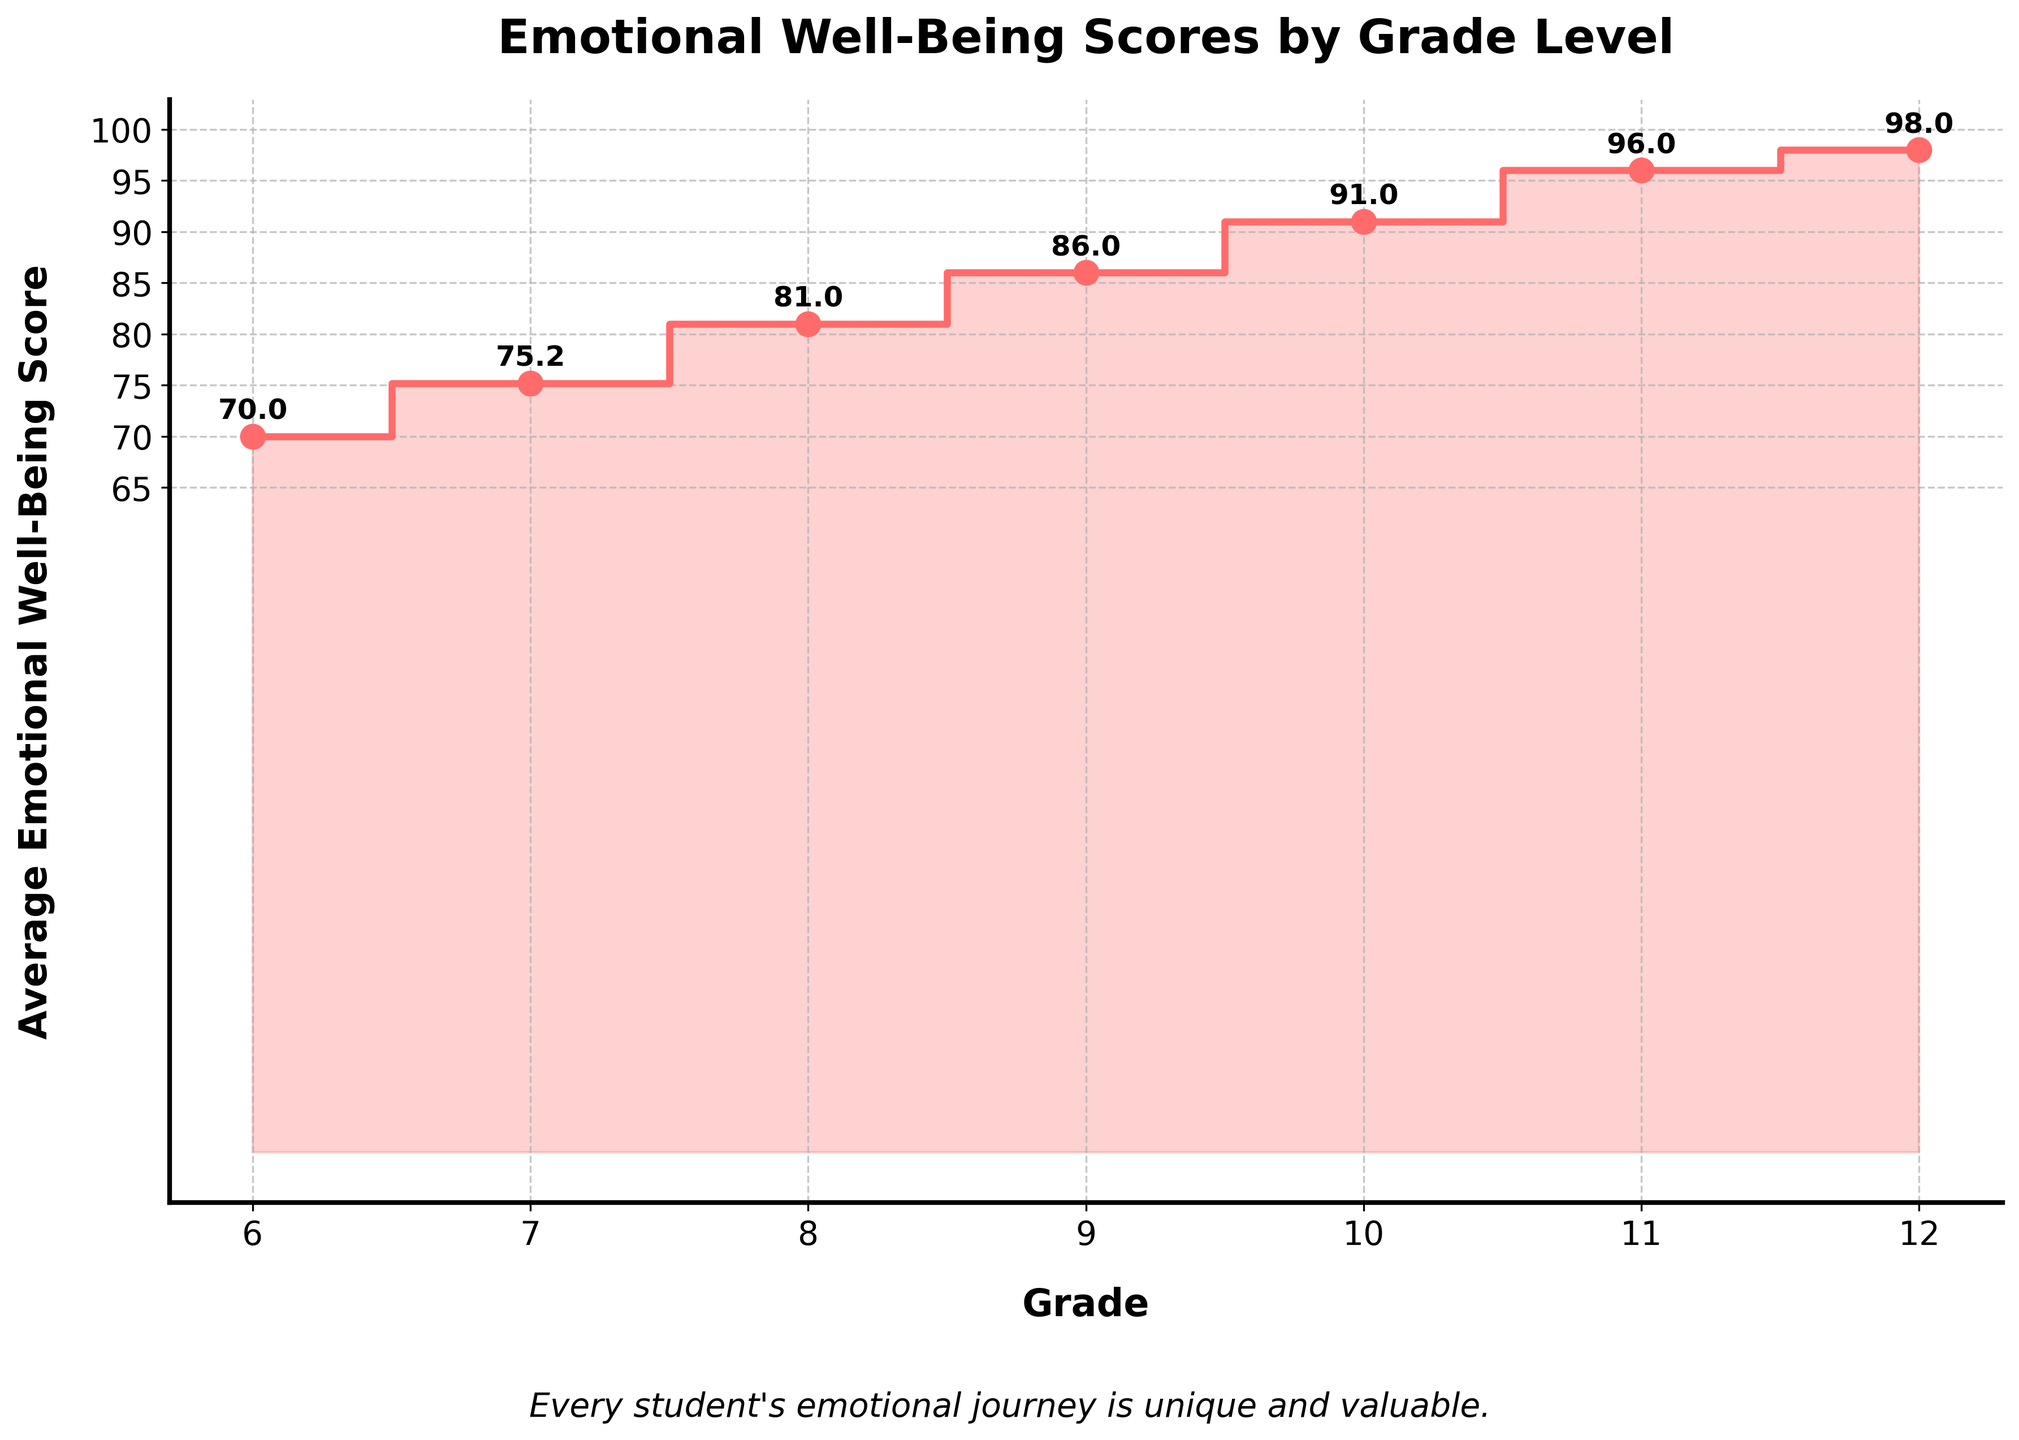What is the title of the plot? The title of the plot is located at the top center and is written in a bold font.
Answer: Emotional Well-Being Scores by Grade Level What color is used for the stair plot's line and filled area? The stair plot's line and the filled area under the line are both colored, which is visually evident in the plot.
Answer: Red Which grade has the highest average emotional well-being score? By looking at the plot and identifying the grade level with the highest point on the y-axis, it shows the highest average emotional well-being score.
Answer: 12 What's the difference in average emotional well-being scores between grade 10 and grade 11? The plot shows the average emotional well-being scores for each grade. The average for grade 10 is around 91 and for grade 11 is around 96. The difference is 96 - 91.
Answer: 5 How does the average emotional well-being score change from grade 6 to grade 7? From the plot, observe the vertical change between the points corresponding to grade 6 and grade 7. Grade 6 is around 70 and Grade 7 is around 75. The change is 75 - 70.
Answer: It increases by 5 Which grade has the lowest average emotional well-being score? Identify the grade level with the lowest point on the y-axis, which shows the lowest average emotional well-being score.
Answer: 6 What is the trend in the average emotional well-being scores as the grade levels increase? Observe how the average scores change as the grade levels move from 6 to 12. There's an upward trend seen from the plot.
Answer: Increasing trend What is the average emotional well-being score for grade 9? Look at the point on the plot corresponding to grade 9 and read off the y-axis value.
Answer: Around 86 What is the emotional well-being score difference between grades 9 and 12? From the plot, note the average scores for grades 9 and 12. Grade 9 is around 86 and grade 12 is around 98. The difference is 98 - 86.
Answer: 12 How many distinct grade levels are represented in the plot? The x-axis of the plot lists the distinct grade levels shown. By counting these grade labels, we get the number of grades.
Answer: 7 